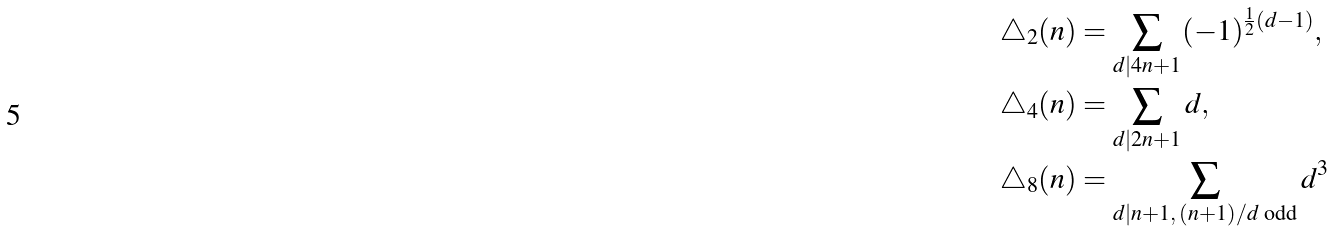Convert formula to latex. <formula><loc_0><loc_0><loc_500><loc_500>\triangle _ { 2 } ( n ) & = \sum _ { d | 4 n + 1 } ( - 1 ) ^ { \frac { 1 } { 2 } ( d - 1 ) } , \\ \triangle _ { 4 } ( n ) & = \sum _ { d | 2 n + 1 } d , \\ \triangle _ { 8 } ( n ) & = \sum _ { d | n + 1 , \, ( n + 1 ) / d \text { odd} } d ^ { 3 }</formula> 